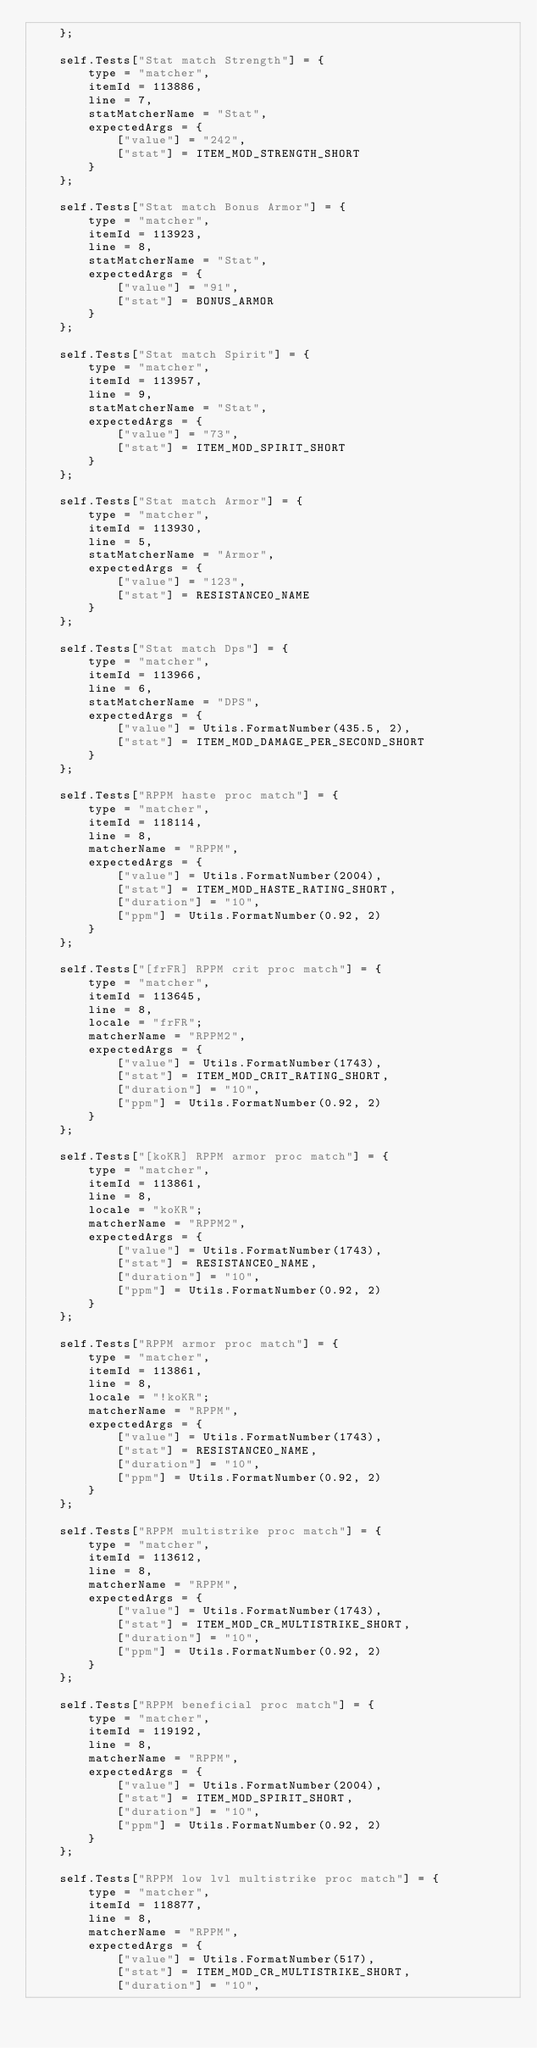<code> <loc_0><loc_0><loc_500><loc_500><_Lua_>    };

    self.Tests["Stat match Strength"] = {
        type = "matcher",
        itemId = 113886,
        line = 7,
        statMatcherName = "Stat",
        expectedArgs = {
            ["value"] = "242",
            ["stat"] = ITEM_MOD_STRENGTH_SHORT
        }
    };

    self.Tests["Stat match Bonus Armor"] = {
        type = "matcher",
        itemId = 113923,
        line = 8,
        statMatcherName = "Stat",
        expectedArgs = {
            ["value"] = "91",
            ["stat"] = BONUS_ARMOR
        }
    };

    self.Tests["Stat match Spirit"] = {
        type = "matcher",
        itemId = 113957,
        line = 9,
        statMatcherName = "Stat",
        expectedArgs = {
            ["value"] = "73",
            ["stat"] = ITEM_MOD_SPIRIT_SHORT
        }
    };

    self.Tests["Stat match Armor"] = {
        type = "matcher",
        itemId = 113930,
        line = 5,
        statMatcherName = "Armor",
        expectedArgs = {
            ["value"] = "123",
            ["stat"] = RESISTANCE0_NAME
        }
    };

    self.Tests["Stat match Dps"] = {
        type = "matcher",
        itemId = 113966,
        line = 6,
        statMatcherName = "DPS",
        expectedArgs = {
            ["value"] = Utils.FormatNumber(435.5, 2),
            ["stat"] = ITEM_MOD_DAMAGE_PER_SECOND_SHORT
        }
    };

    self.Tests["RPPM haste proc match"] = {
        type = "matcher",
        itemId = 118114,
        line = 8,
        matcherName = "RPPM",
        expectedArgs = {
            ["value"] = Utils.FormatNumber(2004),
            ["stat"] = ITEM_MOD_HASTE_RATING_SHORT,
            ["duration"] = "10",
            ["ppm"] = Utils.FormatNumber(0.92, 2)
        }
    };

    self.Tests["[frFR] RPPM crit proc match"] = {
        type = "matcher",
        itemId = 113645,
        line = 8,
        locale = "frFR";
        matcherName = "RPPM2",
        expectedArgs = {
            ["value"] = Utils.FormatNumber(1743),
            ["stat"] = ITEM_MOD_CRIT_RATING_SHORT,
            ["duration"] = "10",
            ["ppm"] = Utils.FormatNumber(0.92, 2)
        }
    };

    self.Tests["[koKR] RPPM armor proc match"] = {
        type = "matcher",
        itemId = 113861,
        line = 8,
        locale = "koKR";
        matcherName = "RPPM2",
        expectedArgs = {
            ["value"] = Utils.FormatNumber(1743),
            ["stat"] = RESISTANCE0_NAME,
            ["duration"] = "10",
            ["ppm"] = Utils.FormatNumber(0.92, 2)
        }
    };

    self.Tests["RPPM armor proc match"] = {
        type = "matcher",
        itemId = 113861,
        line = 8,
        locale = "!koKR";
        matcherName = "RPPM",
        expectedArgs = {
            ["value"] = Utils.FormatNumber(1743),
            ["stat"] = RESISTANCE0_NAME,
            ["duration"] = "10",
            ["ppm"] = Utils.FormatNumber(0.92, 2)
        }
    };

    self.Tests["RPPM multistrike proc match"] = {
        type = "matcher",
        itemId = 113612,
        line = 8,
        matcherName = "RPPM",
        expectedArgs = {
            ["value"] = Utils.FormatNumber(1743),
            ["stat"] = ITEM_MOD_CR_MULTISTRIKE_SHORT,
            ["duration"] = "10",
            ["ppm"] = Utils.FormatNumber(0.92, 2)
        }
    };

    self.Tests["RPPM beneficial proc match"] = {
        type = "matcher",
        itemId = 119192,
        line = 8,
        matcherName = "RPPM",
        expectedArgs = {
            ["value"] = Utils.FormatNumber(2004),
            ["stat"] = ITEM_MOD_SPIRIT_SHORT,
            ["duration"] = "10",
            ["ppm"] = Utils.FormatNumber(0.92, 2)
        }
    };

    self.Tests["RPPM low lvl multistrike proc match"] = {
        type = "matcher",
        itemId = 118877,
        line = 8,
        matcherName = "RPPM",
        expectedArgs = {
            ["value"] = Utils.FormatNumber(517),
            ["stat"] = ITEM_MOD_CR_MULTISTRIKE_SHORT,
            ["duration"] = "10",</code> 